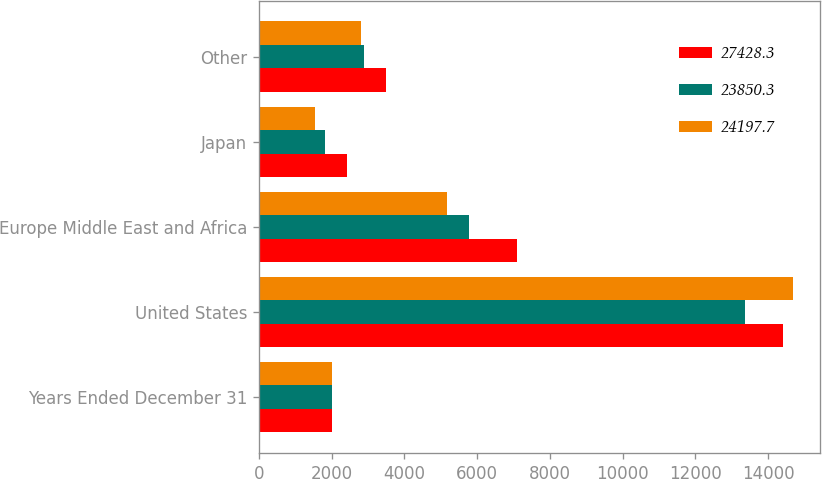Convert chart to OTSL. <chart><loc_0><loc_0><loc_500><loc_500><stacked_bar_chart><ecel><fcel>Years Ended December 31<fcel>United States<fcel>Europe Middle East and Africa<fcel>Japan<fcel>Other<nl><fcel>27428.3<fcel>2009<fcel>14401.2<fcel>7093.1<fcel>2425.6<fcel>3508.4<nl><fcel>23850.3<fcel>2008<fcel>13370.5<fcel>5773.8<fcel>1823.5<fcel>2882.5<nl><fcel>24197.7<fcel>2007<fcel>14690.9<fcel>5159<fcel>1533.2<fcel>2814.6<nl></chart> 